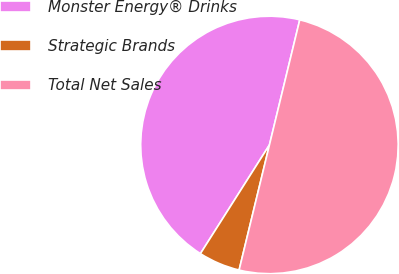Convert chart to OTSL. <chart><loc_0><loc_0><loc_500><loc_500><pie_chart><fcel>Monster Energy® Drinks<fcel>Strategic Brands<fcel>Total Net Sales<nl><fcel>44.78%<fcel>5.22%<fcel>50.0%<nl></chart> 